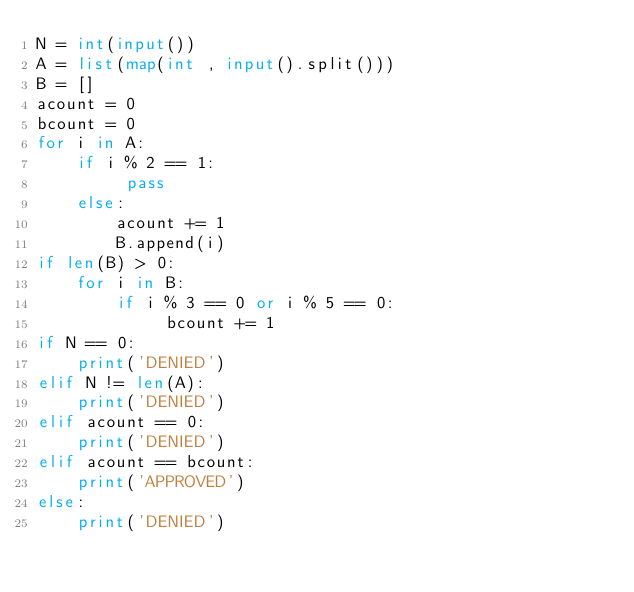Convert code to text. <code><loc_0><loc_0><loc_500><loc_500><_Python_>N = int(input())
A = list(map(int , input().split()))
B = []
acount = 0
bcount = 0
for i in A:
    if i % 2 == 1:
         pass
    else:
        acount += 1
        B.append(i)
if len(B) > 0:
    for i in B:
        if i % 3 == 0 or i % 5 == 0:
             bcount += 1
if N == 0:
    print('DENIED')
elif N != len(A):
    print('DENIED')
elif acount == 0:
    print('DENIED')
elif acount == bcount:
    print('APPROVED')
else:
    print('DENIED')    </code> 